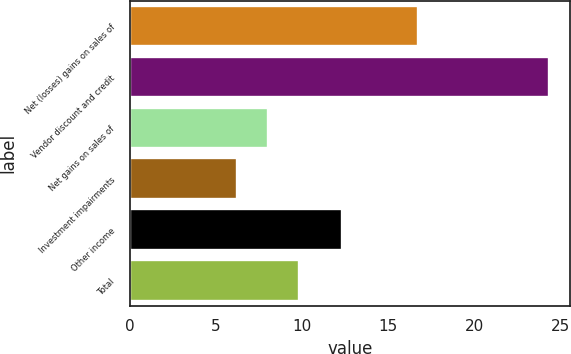<chart> <loc_0><loc_0><loc_500><loc_500><bar_chart><fcel>Net (losses) gains on sales of<fcel>Vendor discount and credit<fcel>Net gains on sales of<fcel>Investment impairments<fcel>Other income<fcel>Total<nl><fcel>16.7<fcel>24.3<fcel>8.01<fcel>6.2<fcel>12.3<fcel>9.82<nl></chart> 